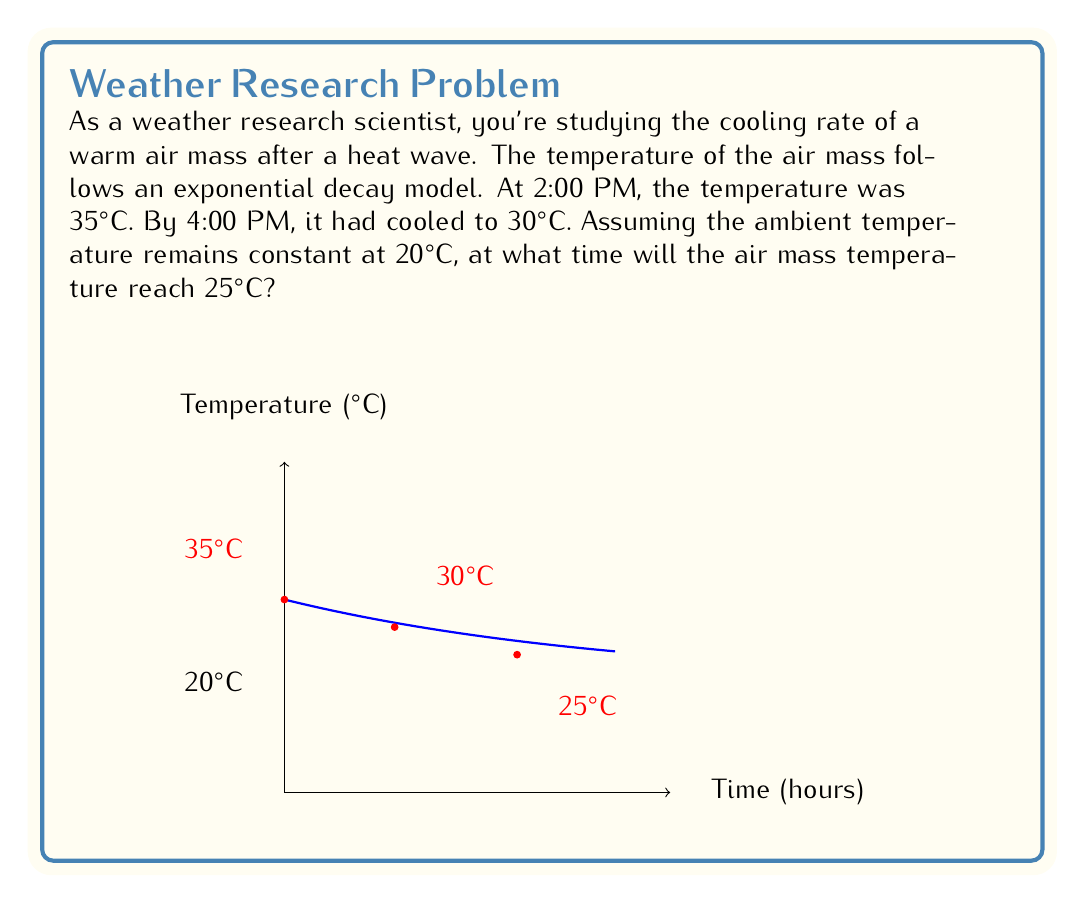Can you solve this math problem? Let's solve this step-by-step using the exponential decay model:

1) The general form of exponential decay is:
   $T(t) = (T_0 - T_a)e^{-kt} + T_a$
   where $T(t)$ is temperature at time $t$, $T_0$ is initial temperature, $T_a$ is ambient temperature, and $k$ is the decay constant.

2) We know:
   $T_a = 20°C$
   $T_0 = 35°C$ at $t = 0$ (2:00 PM)
   $T(2) = 30°C$ at $t = 2$ (4:00 PM)

3) Substituting into the equation:
   $30 = (35 - 20)e^{-2k} + 20$

4) Solving for $k$:
   $10 = 15e^{-2k}$
   $\frac{2}{3} = e^{-2k}$
   $\ln(\frac{2}{3}) = -2k$
   $k = -\frac{1}{2}\ln(\frac{2}{3}) \approx 0.2027$

5) Now we have the complete model:
   $T(t) = 15e^{-0.2027t} + 20$

6) To find when temperature reaches 25°C, solve:
   $25 = 15e^{-0.2027t} + 20$
   $5 = 15e^{-0.2027t}$
   $\frac{1}{3} = e^{-0.2027t}$
   $\ln(\frac{1}{3}) = -0.2027t$
   $t = -\frac{\ln(\frac{1}{3})}{0.2027} \approx 4.2219$ hours

7) 4.2219 hours after 2:00 PM is approximately 6:13 PM.
Answer: 6:13 PM 